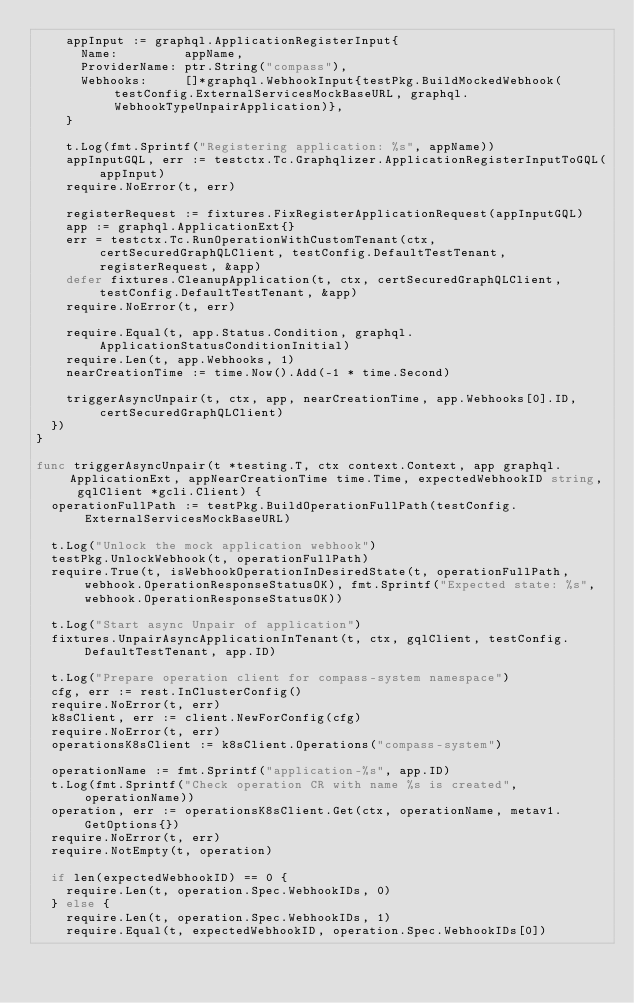Convert code to text. <code><loc_0><loc_0><loc_500><loc_500><_Go_>		appInput := graphql.ApplicationRegisterInput{
			Name:         appName,
			ProviderName: ptr.String("compass"),
			Webhooks:     []*graphql.WebhookInput{testPkg.BuildMockedWebhook(testConfig.ExternalServicesMockBaseURL, graphql.WebhookTypeUnpairApplication)},
		}

		t.Log(fmt.Sprintf("Registering application: %s", appName))
		appInputGQL, err := testctx.Tc.Graphqlizer.ApplicationRegisterInputToGQL(appInput)
		require.NoError(t, err)

		registerRequest := fixtures.FixRegisterApplicationRequest(appInputGQL)
		app := graphql.ApplicationExt{}
		err = testctx.Tc.RunOperationWithCustomTenant(ctx, certSecuredGraphQLClient, testConfig.DefaultTestTenant, registerRequest, &app)
		defer fixtures.CleanupApplication(t, ctx, certSecuredGraphQLClient, testConfig.DefaultTestTenant, &app)
		require.NoError(t, err)

		require.Equal(t, app.Status.Condition, graphql.ApplicationStatusConditionInitial)
		require.Len(t, app.Webhooks, 1)
		nearCreationTime := time.Now().Add(-1 * time.Second)

		triggerAsyncUnpair(t, ctx, app, nearCreationTime, app.Webhooks[0].ID, certSecuredGraphQLClient)
	})
}

func triggerAsyncUnpair(t *testing.T, ctx context.Context, app graphql.ApplicationExt, appNearCreationTime time.Time, expectedWebhookID string, gqlClient *gcli.Client) {
	operationFullPath := testPkg.BuildOperationFullPath(testConfig.ExternalServicesMockBaseURL)

	t.Log("Unlock the mock application webhook")
	testPkg.UnlockWebhook(t, operationFullPath)
	require.True(t, isWebhookOperationInDesiredState(t, operationFullPath, webhook.OperationResponseStatusOK), fmt.Sprintf("Expected state: %s", webhook.OperationResponseStatusOK))

	t.Log("Start async Unpair of application")
	fixtures.UnpairAsyncApplicationInTenant(t, ctx, gqlClient, testConfig.DefaultTestTenant, app.ID)

	t.Log("Prepare operation client for compass-system namespace")
	cfg, err := rest.InClusterConfig()
	require.NoError(t, err)
	k8sClient, err := client.NewForConfig(cfg)
	require.NoError(t, err)
	operationsK8sClient := k8sClient.Operations("compass-system")

	operationName := fmt.Sprintf("application-%s", app.ID)
	t.Log(fmt.Sprintf("Check operation CR with name %s is created", operationName))
	operation, err := operationsK8sClient.Get(ctx, operationName, metav1.GetOptions{})
	require.NoError(t, err)
	require.NotEmpty(t, operation)

	if len(expectedWebhookID) == 0 {
		require.Len(t, operation.Spec.WebhookIDs, 0)
	} else {
		require.Len(t, operation.Spec.WebhookIDs, 1)
		require.Equal(t, expectedWebhookID, operation.Spec.WebhookIDs[0])
</code> 